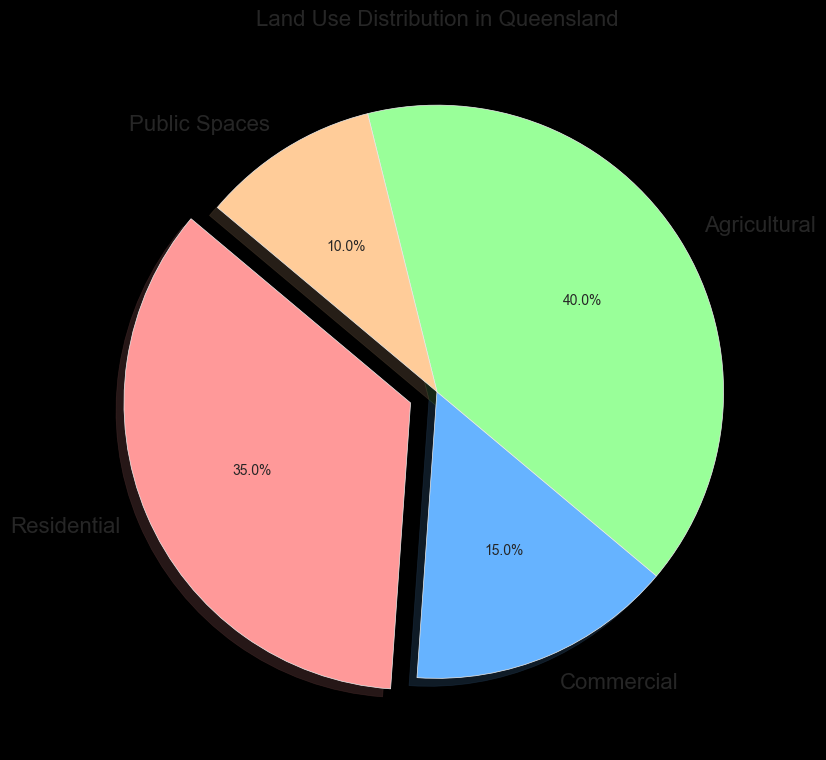What percentage of land use is dedicated to Residential? The Residential category in the pie chart shows its percentage slice, which is labeled as 35%.
Answer: 35% Which category has the smallest land use percentage? By observing the pie chart, the slice for Public Spaces appears the smallest, labeled 10%.
Answer: Public Spaces How much larger is the Residential land use compared to Commercial land use? The Residential use is 35% while Commercial is 15%. The difference is 35% - 15% = 20%.
Answer: 20% What is the combined percentage of Agricultural and Public Spaces land use? The Agricultural land use percentage is 40% and the Public Spaces land use percentage is 10%. The combined percentage is 40% + 10% = 50%.
Answer: 50% Is Commercial land use greater than Agricultural land use? Comparing the percentages, Commercial is 15% and Agricultural is 40%. Since 15% is less than 40%, Commercial land use is not greater than Agricultural land use.
Answer: No What color represents Agricultural land use in the pie chart? The Agricultural slice of the pie chart is colored in a light green hue.
Answer: Light green By how much does the Agricultural land use exceed the Public Spaces land use? Agricultural land use is 40% and Public Spaces land use is 10%. The difference is 40% - 10% = 30%.
Answer: 30% What is the difference between the largest and smallest land use categories? The largest land use category is Agricultural at 40%, and the smallest is Public Spaces at 10%. The difference is 40% - 10% = 30%.
Answer: 30% Which land use category, Residential or Public Spaces, has a greater percentage? Looking at the pie chart, Residential has 35% and Public Spaces has 10%. Since 35% > 10%, Residential has a greater percentage.
Answer: Residential Describe the appearance of the Residential section of the pie chart. The Residential section appears as a red slice, slightly exploded outward, and it's labeled 35%.
Answer: Red slice, exploded, 35% 